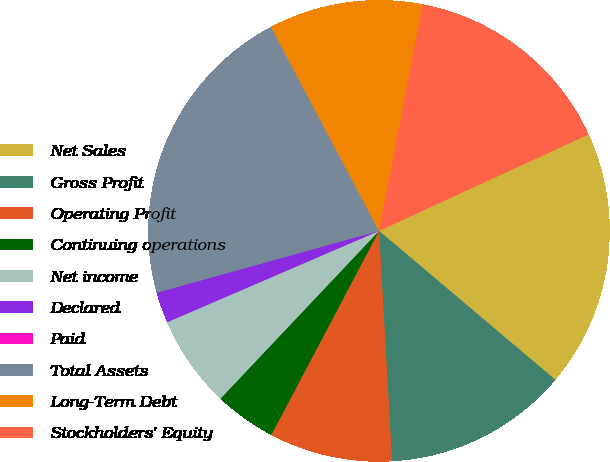Convert chart to OTSL. <chart><loc_0><loc_0><loc_500><loc_500><pie_chart><fcel>Net Sales<fcel>Gross Profit<fcel>Operating Profit<fcel>Continuing operations<fcel>Net income<fcel>Declared<fcel>Paid<fcel>Total Assets<fcel>Long-Term Debt<fcel>Stockholders' Equity<nl><fcel>18.03%<fcel>12.94%<fcel>8.63%<fcel>4.32%<fcel>6.47%<fcel>2.16%<fcel>0.0%<fcel>21.57%<fcel>10.79%<fcel>15.1%<nl></chart> 